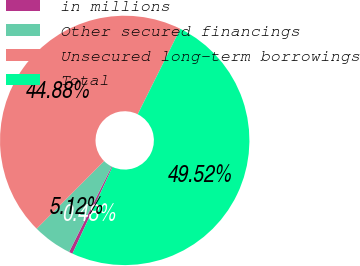Convert chart to OTSL. <chart><loc_0><loc_0><loc_500><loc_500><pie_chart><fcel>in millions<fcel>Other secured financings<fcel>Unsecured long-term borrowings<fcel>Total<nl><fcel>0.48%<fcel>5.12%<fcel>44.88%<fcel>49.52%<nl></chart> 